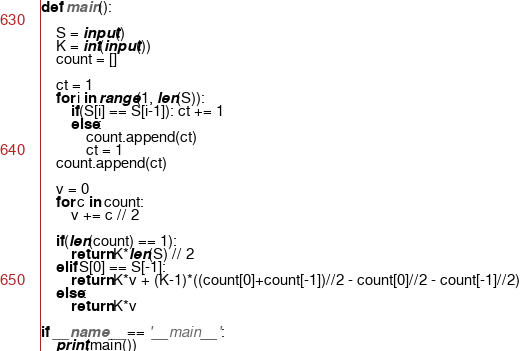Convert code to text. <code><loc_0><loc_0><loc_500><loc_500><_Python_>def main():

    S = input()
    K = int(input())
    count = []

    ct = 1
    for i in range(1, len(S)):
        if(S[i] == S[i-1]): ct += 1
        else:
            count.append(ct)
            ct = 1
    count.append(ct)

    v = 0
    for c in count:
        v += c // 2

    if(len(count) == 1):
        return K*len(S) // 2
    elif S[0] == S[-1]:
        return K*v + (K-1)*((count[0]+count[-1])//2 - count[0]//2 - count[-1]//2)
    else:
        return K*v

if __name__ == '__main__':
    print(main())</code> 